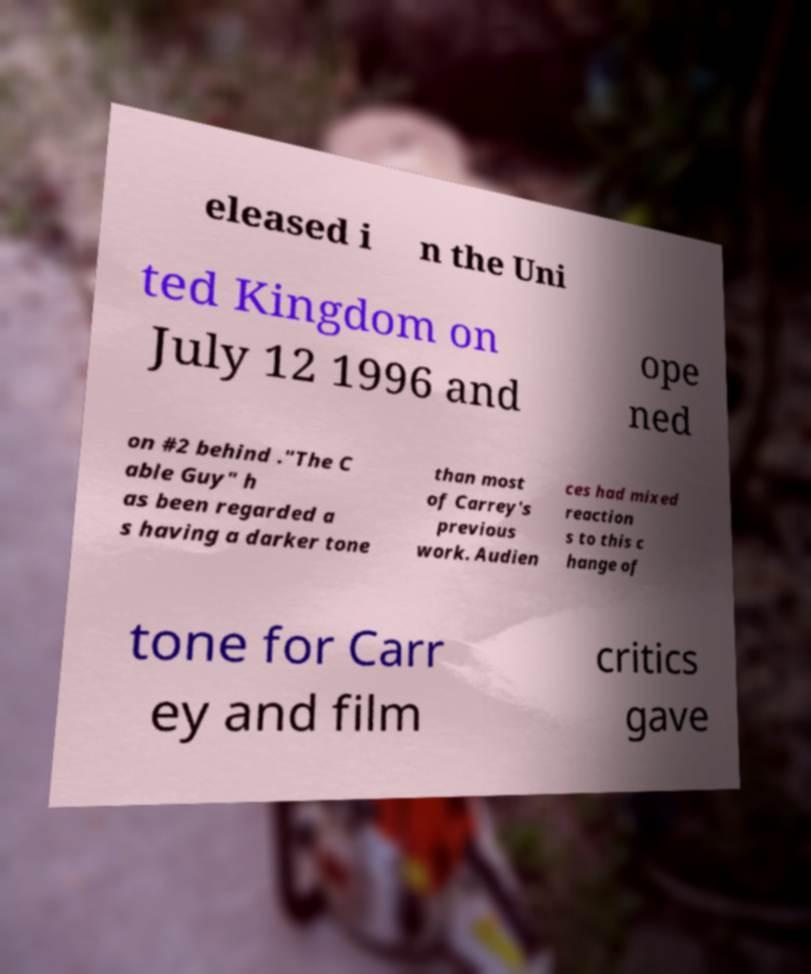I need the written content from this picture converted into text. Can you do that? eleased i n the Uni ted Kingdom on July 12 1996 and ope ned on #2 behind ."The C able Guy" h as been regarded a s having a darker tone than most of Carrey's previous work. Audien ces had mixed reaction s to this c hange of tone for Carr ey and film critics gave 